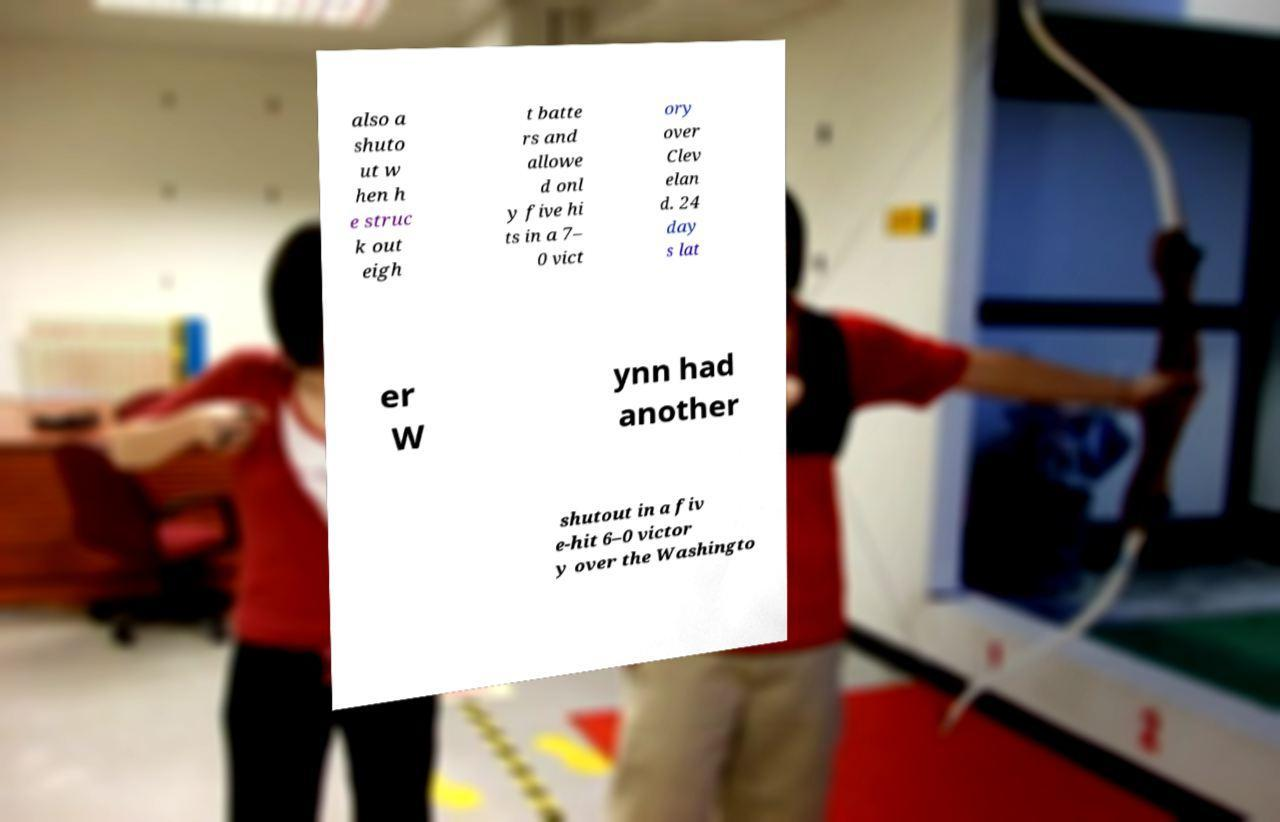What messages or text are displayed in this image? I need them in a readable, typed format. also a shuto ut w hen h e struc k out eigh t batte rs and allowe d onl y five hi ts in a 7– 0 vict ory over Clev elan d. 24 day s lat er W ynn had another shutout in a fiv e-hit 6–0 victor y over the Washingto 